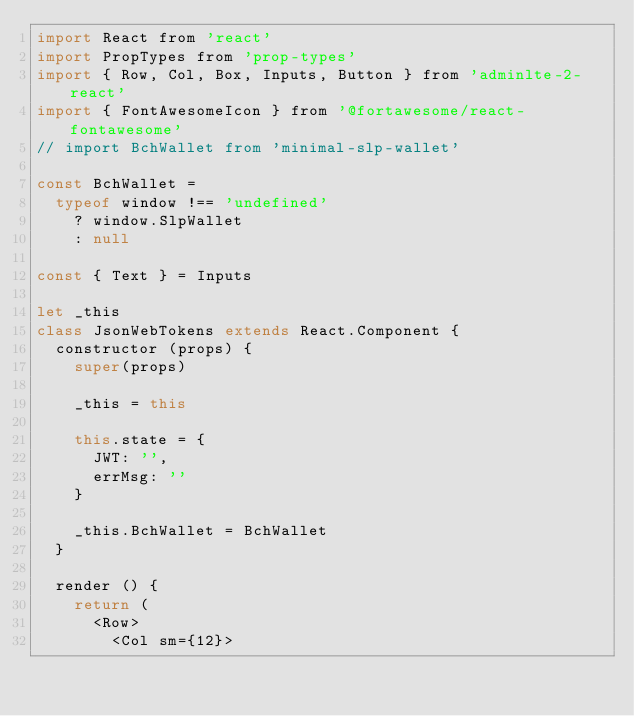Convert code to text. <code><loc_0><loc_0><loc_500><loc_500><_JavaScript_>import React from 'react'
import PropTypes from 'prop-types'
import { Row, Col, Box, Inputs, Button } from 'adminlte-2-react'
import { FontAwesomeIcon } from '@fortawesome/react-fontawesome'
// import BchWallet from 'minimal-slp-wallet'

const BchWallet =
  typeof window !== 'undefined'
    ? window.SlpWallet
    : null

const { Text } = Inputs

let _this
class JsonWebTokens extends React.Component {
  constructor (props) {
    super(props)

    _this = this

    this.state = {
      JWT: '',
      errMsg: ''
    }

    _this.BchWallet = BchWallet
  }

  render () {
    return (
      <Row>
        <Col sm={12}></code> 